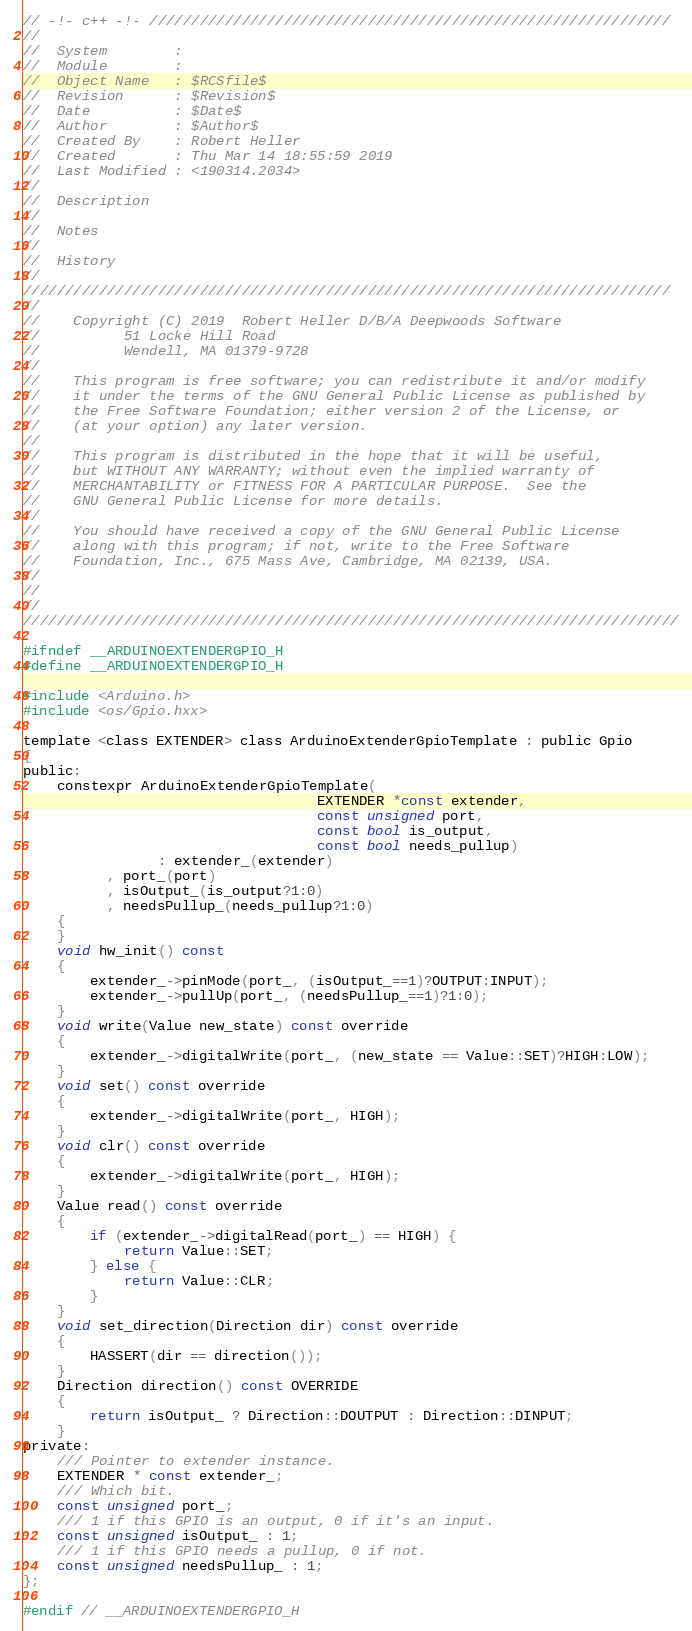Convert code to text. <code><loc_0><loc_0><loc_500><loc_500><_C_>// -!- c++ -!- //////////////////////////////////////////////////////////////
//
//  System        : 
//  Module        : 
//  Object Name   : $RCSfile$
//  Revision      : $Revision$
//  Date          : $Date$
//  Author        : $Author$
//  Created By    : Robert Heller
//  Created       : Thu Mar 14 18:55:59 2019
//  Last Modified : <190314.2034>
//
//  Description	
//
//  Notes
//
//  History
//	
/////////////////////////////////////////////////////////////////////////////
//
//    Copyright (C) 2019  Robert Heller D/B/A Deepwoods Software
//			51 Locke Hill Road
//			Wendell, MA 01379-9728
//
//    This program is free software; you can redistribute it and/or modify
//    it under the terms of the GNU General Public License as published by
//    the Free Software Foundation; either version 2 of the License, or
//    (at your option) any later version.
//
//    This program is distributed in the hope that it will be useful,
//    but WITHOUT ANY WARRANTY; without even the implied warranty of
//    MERCHANTABILITY or FITNESS FOR A PARTICULAR PURPOSE.  See the
//    GNU General Public License for more details.
//
//    You should have received a copy of the GNU General Public License
//    along with this program; if not, write to the Free Software
//    Foundation, Inc., 675 Mass Ave, Cambridge, MA 02139, USA.
//
// 
//
//////////////////////////////////////////////////////////////////////////////

#ifndef __ARDUINOEXTENDERGPIO_H
#define __ARDUINOEXTENDERGPIO_H

#include <Arduino.h>
#include <os/Gpio.hxx>

template <class EXTENDER> class ArduinoExtenderGpioTemplate : public Gpio
{
public:
    constexpr ArduinoExtenderGpioTemplate(
                                   EXTENDER *const extender,
                                   const unsigned port,
                                   const bool is_output,
                                   const bool needs_pullup)
                : extender_(extender)
          , port_(port)
          , isOutput_(is_output?1:0)
          , needsPullup_(needs_pullup?1:0)
    {
    }
    void hw_init() const
    {
        extender_->pinMode(port_, (isOutput_==1)?OUTPUT:INPUT);
        extender_->pullUp(port_, (needsPullup_==1)?1:0);
    }
    void write(Value new_state) const override
    {
        extender_->digitalWrite(port_, (new_state == Value::SET)?HIGH:LOW);
    }
    void set() const override
    {
        extender_->digitalWrite(port_, HIGH);
    }
    void clr() const override
    {
        extender_->digitalWrite(port_, HIGH);
    }
    Value read() const override
    {
        if (extender_->digitalRead(port_) == HIGH) {
            return Value::SET;
        } else {
            return Value::CLR;
        }
    }
    void set_direction(Direction dir) const override
    {
        HASSERT(dir == direction());
    }
    Direction direction() const OVERRIDE
    {
        return isOutput_ ? Direction::DOUTPUT : Direction::DINPUT;
    }
private:
    /// Pointer to extender instance.
    EXTENDER * const extender_;
    /// Which bit.
    const unsigned port_;
    /// 1 if this GPIO is an output, 0 if it's an input.
    const unsigned isOutput_ : 1;
    /// 1 if this GPIO needs a pullup, 0 if not.
    const unsigned needsPullup_ : 1;
};

#endif // __ARDUINOEXTENDERGPIO_H

</code> 